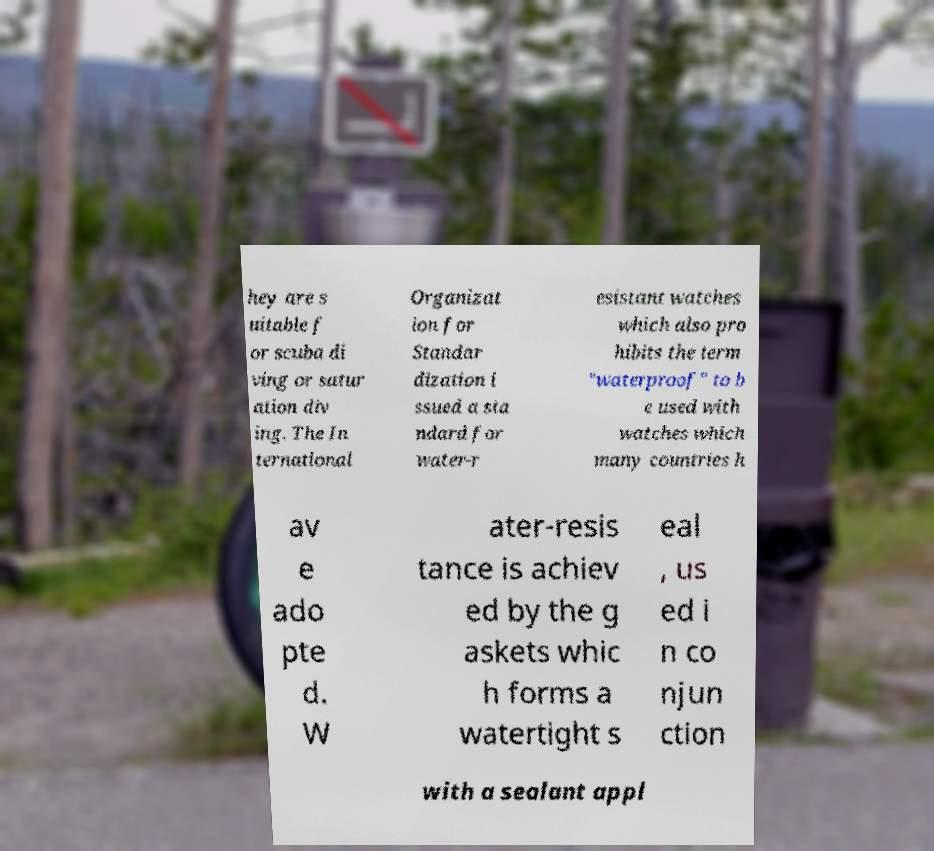What messages or text are displayed in this image? I need them in a readable, typed format. hey are s uitable f or scuba di ving or satur ation div ing. The In ternational Organizat ion for Standar dization i ssued a sta ndard for water-r esistant watches which also pro hibits the term "waterproof" to b e used with watches which many countries h av e ado pte d. W ater-resis tance is achiev ed by the g askets whic h forms a watertight s eal , us ed i n co njun ction with a sealant appl 